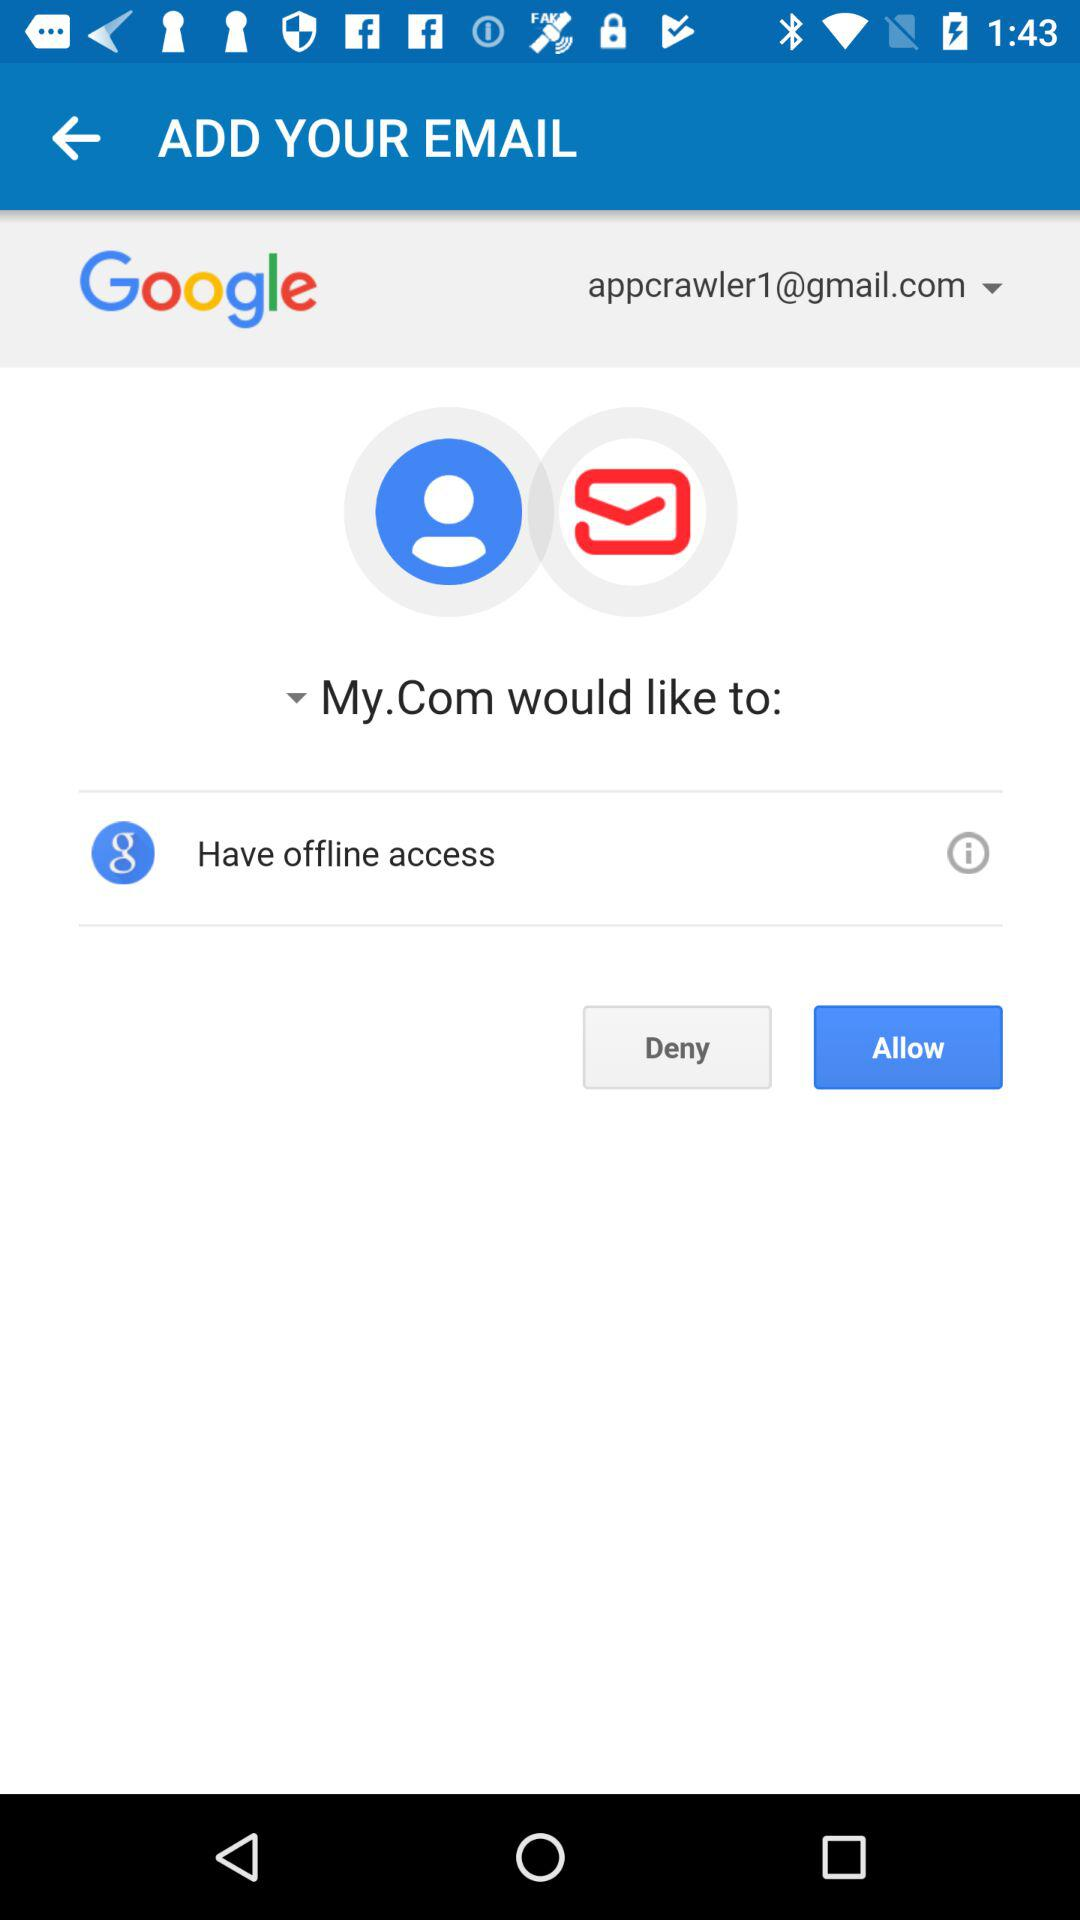What is the selected option? The selected options are "appcrawler1@gmail.com" and "My.Com would like to:". 